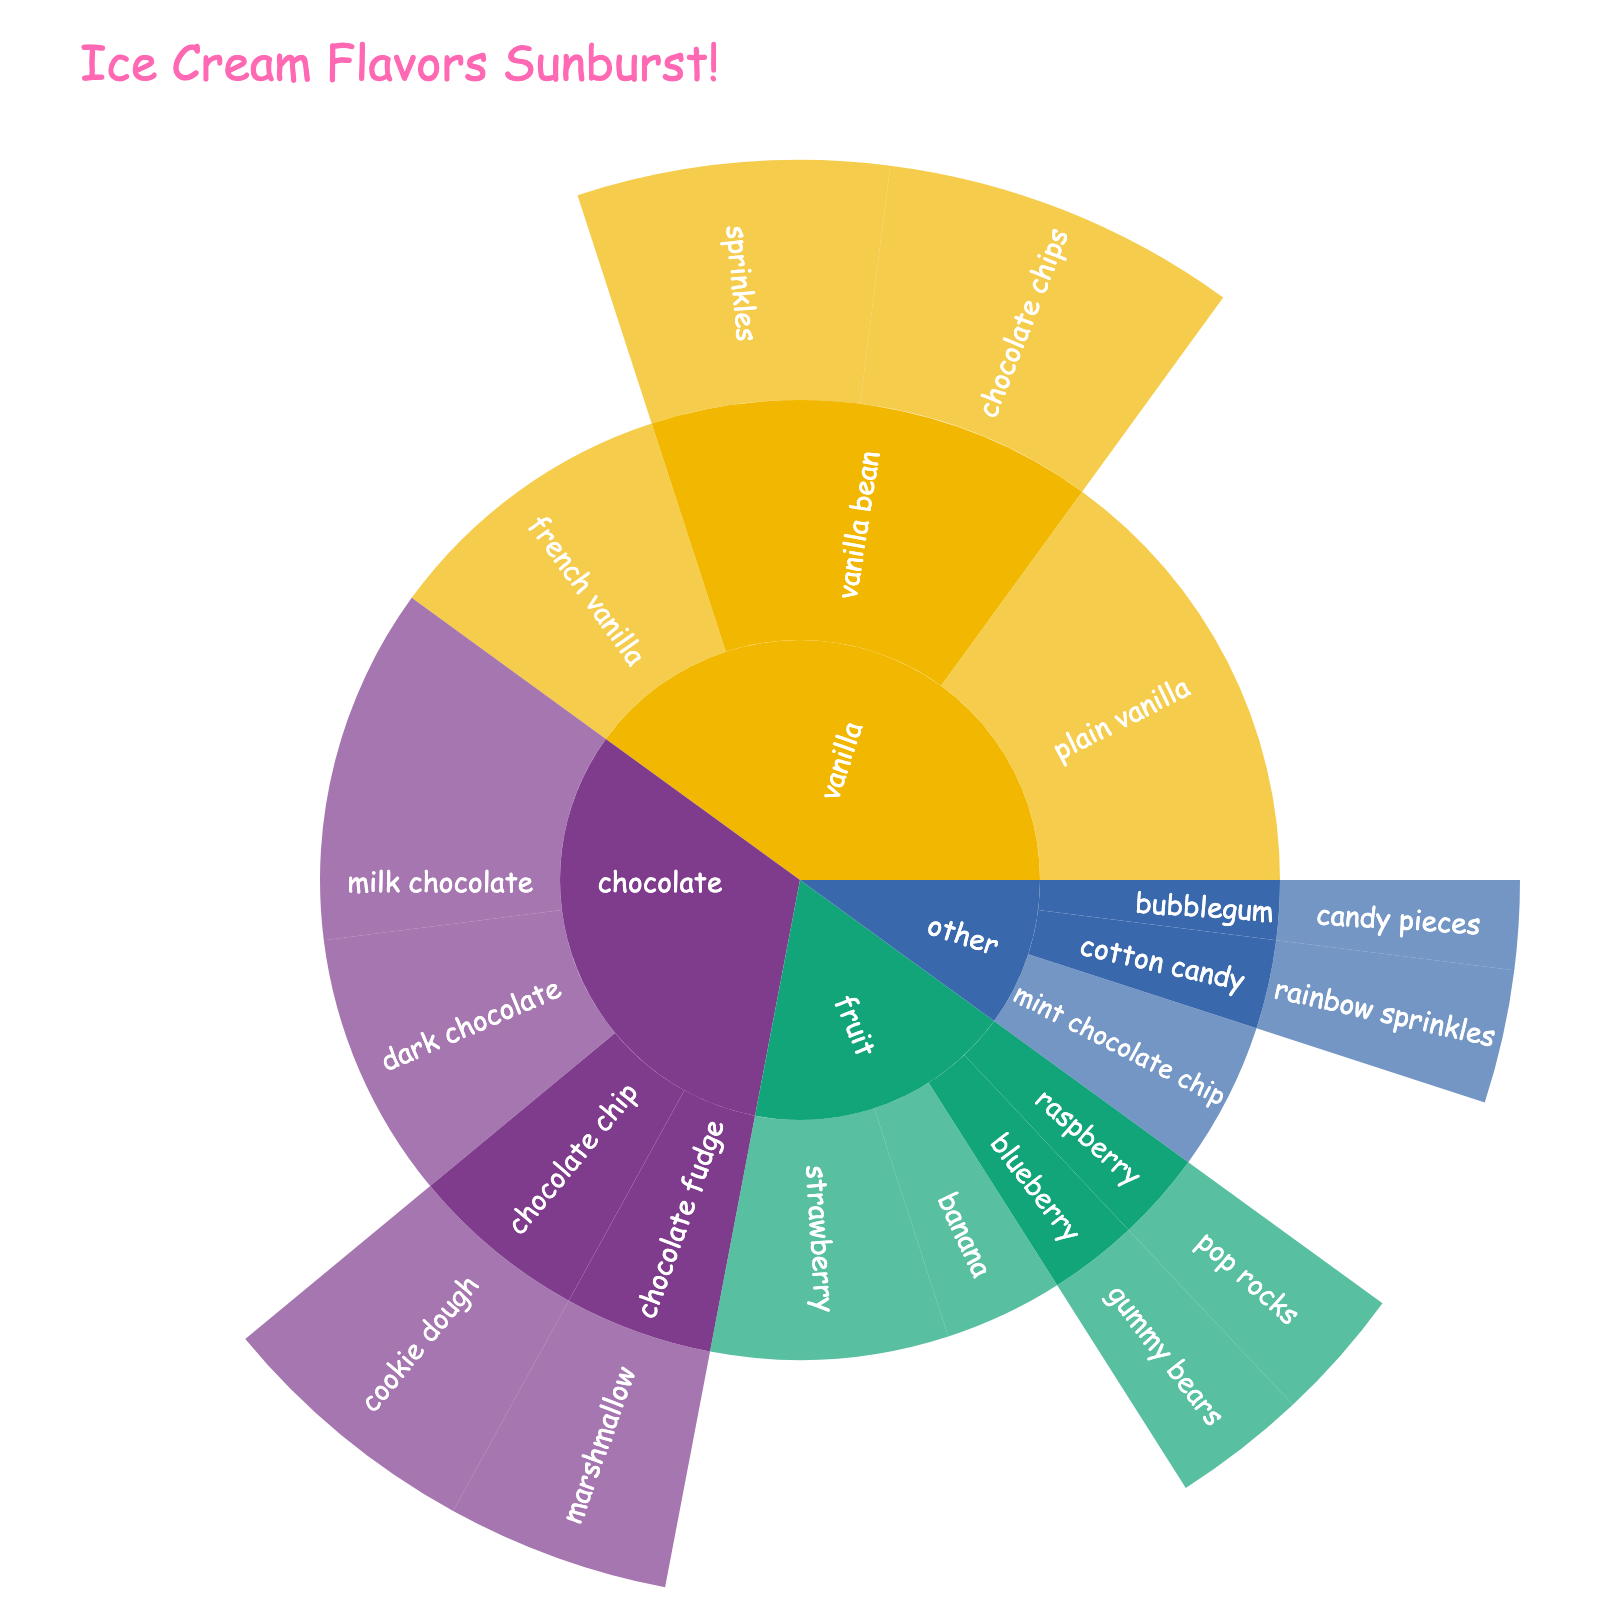What is the title of the sunburst plot? The title is displayed at the top of the plot, usually in larger and bolder text.
Answer: Ice Cream Flavors Sunburst! Which base flavor has the highest percentage of kids liking it without any mix-ins? Look for the largest segment in the outer ring that doesn't specify a mix-in, then check its base flavor.
Answer: vanilla How much more popular is plain vanilla compared to french vanilla? Find the segments for plain vanilla and french vanilla. Subtract the percentage of french vanilla from plain vanilla. 15% - 10% = 5%.
Answer: 5% Among the chocolate-based flavors, which mix-in combination is liked by the least percentage of kids? Within the chocolate section, look for the smallest segment related to a mix-in combination.
Answer: chocolate fudge-marshmallow What is the total percentage of kids who like vanilla-based ice creams? Sum the percentages of all vanilla-based segments: 15% (plain) + 10% (french) + 8% (vanilla bean, chocolate chips) + 7% (vanilla bean, sprinkles) = 40%.
Answer: 40% Which base flavor has the most diversity in mix-ins? Count the different mix-ins within each base flavor's section. Chocolate has 'cookie dough', 'marshmallow' indicating two different mix-in types.
Answer: chocolate What is the percentage difference between the most popular fruit-based flavor and the least popular one? Find the percentages for strawberry (most popular at 8%) and blueberry with gummy bears or raspberry with pop rocks (least popular both at 3%). The difference is 5%.
Answer: 5% Which flavor has more mix-ins, vanilla bean or chocolate chip? Compare the number of unique mix-ins listed under each flavor. Vanilla bean has two (chocolate chips, sprinkles), while chocolate chip has one (cookie dough).
Answer: vanilla bean What percentage of kids like flavors from the 'other' category? Sum the percentages of all flavors in the 'other' base category: 5% (mint chocolate chip) + 3% (cotton candy) + 2% (bubblegum) = 10%.
Answer: 10% Which has a higher percentage, dark chocolate or strawberry? Directly compare the segments for dark chocolate and strawberry. Dark chocolate is 9%, and strawberry is 8%.
Answer: dark chocolate 